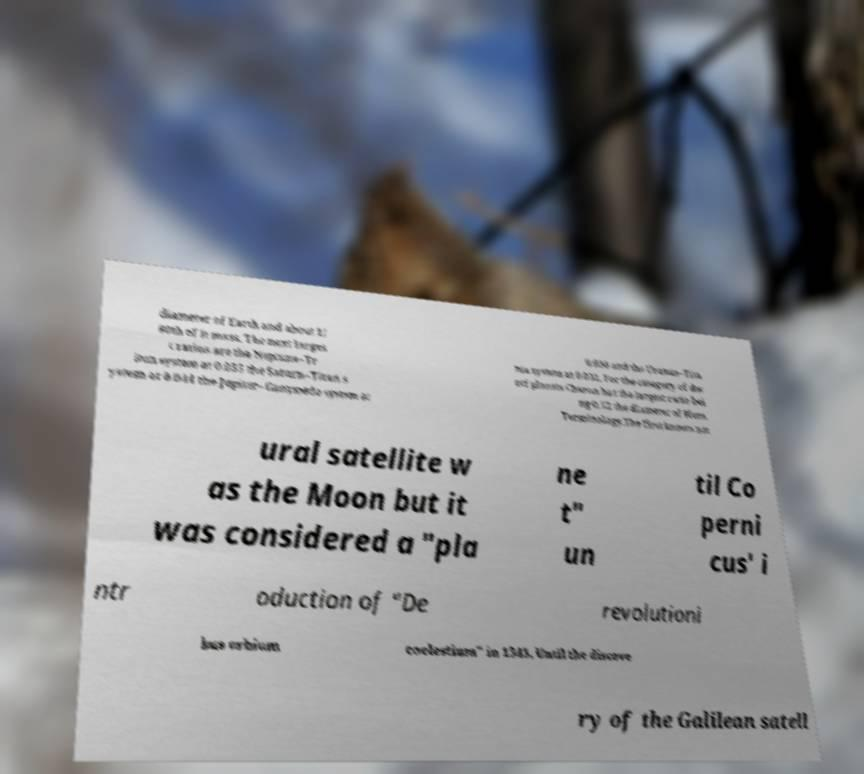Can you accurately transcribe the text from the provided image for me? diameter of Earth and about 1/ 80th of it mass. The next larges t ratios are the Neptune–Tr iton system at 0.055 the Saturn–Titan s ystem at 0.044 the Jupiter–Ganymede system at 0.038 and the Uranus–Tita nia system at 0.031. For the category of dw arf planets Charon has the largest ratio bei ng 0.52 the diameter of Pluto. Terminology.The first known nat ural satellite w as the Moon but it was considered a "pla ne t" un til Co perni cus' i ntr oduction of "De revolutioni bus orbium coelestium" in 1543. Until the discove ry of the Galilean satell 